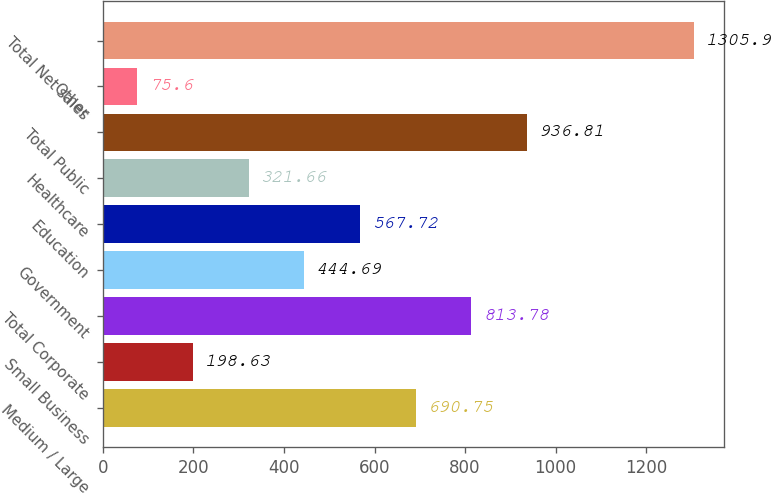Convert chart to OTSL. <chart><loc_0><loc_0><loc_500><loc_500><bar_chart><fcel>Medium / Large<fcel>Small Business<fcel>Total Corporate<fcel>Government<fcel>Education<fcel>Healthcare<fcel>Total Public<fcel>Other<fcel>Total Net sales<nl><fcel>690.75<fcel>198.63<fcel>813.78<fcel>444.69<fcel>567.72<fcel>321.66<fcel>936.81<fcel>75.6<fcel>1305.9<nl></chart> 